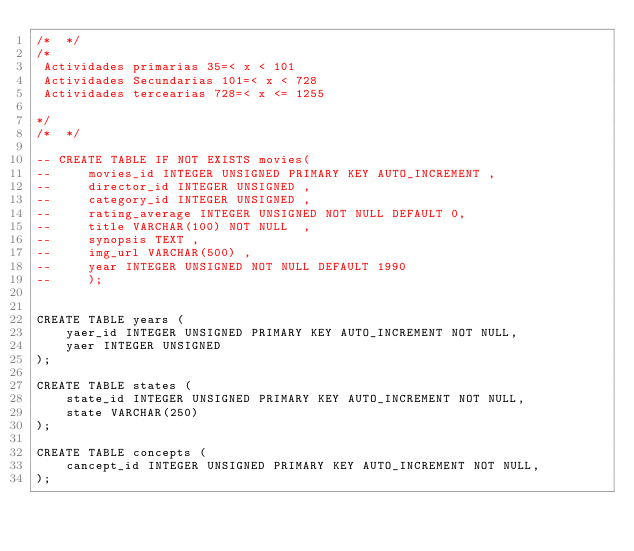<code> <loc_0><loc_0><loc_500><loc_500><_SQL_>/*  */
/*
 Actividades primarias 35=< x < 101
 Actividades Secundarias 101=< x < 728
 Actividades tercearias 728=< x <= 1255

*/
/*  */

-- CREATE TABLE IF NOT EXISTS movies(
--     movies_id INTEGER UNSIGNED PRIMARY KEY AUTO_INCREMENT ,
--     director_id INTEGER UNSIGNED ,
--     category_id INTEGER UNSIGNED ,
--     rating_average INTEGER UNSIGNED NOT NULL DEFAULT 0,
--     title VARCHAR(100) NOT NULL  ,
--     synopsis TEXT ,
--     img_url VARCHAR(500) ,
--     year INTEGER UNSIGNED NOT NULL DEFAULT 1990
--     );


CREATE TABLE years (
    yaer_id INTEGER UNSIGNED PRIMARY KEY AUTO_INCREMENT NOT NULL,
    yaer INTEGER UNSIGNED 
);

CREATE TABLE states (
    state_id INTEGER UNSIGNED PRIMARY KEY AUTO_INCREMENT NOT NULL,
    state VARCHAR(250)
);

CREATE TABLE concepts (
    cancept_id INTEGER UNSIGNED PRIMARY KEY AUTO_INCREMENT NOT NULL,
);</code> 